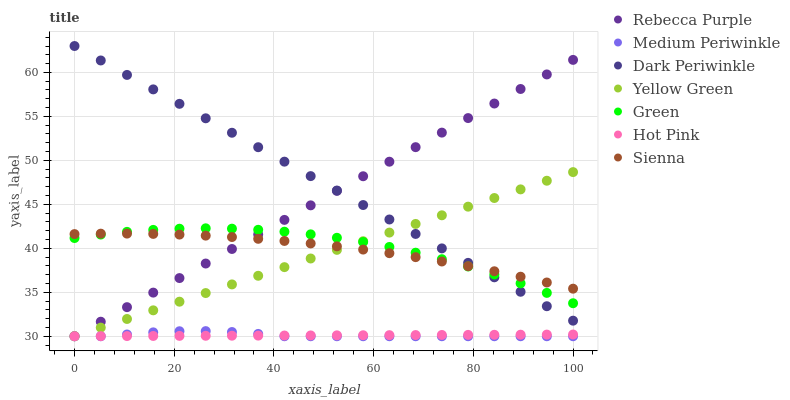Does Hot Pink have the minimum area under the curve?
Answer yes or no. Yes. Does Dark Periwinkle have the maximum area under the curve?
Answer yes or no. Yes. Does Medium Periwinkle have the minimum area under the curve?
Answer yes or no. No. Does Medium Periwinkle have the maximum area under the curve?
Answer yes or no. No. Is Hot Pink the smoothest?
Answer yes or no. Yes. Is Green the roughest?
Answer yes or no. Yes. Is Medium Periwinkle the smoothest?
Answer yes or no. No. Is Medium Periwinkle the roughest?
Answer yes or no. No. Does Yellow Green have the lowest value?
Answer yes or no. Yes. Does Sienna have the lowest value?
Answer yes or no. No. Does Dark Periwinkle have the highest value?
Answer yes or no. Yes. Does Medium Periwinkle have the highest value?
Answer yes or no. No. Is Medium Periwinkle less than Sienna?
Answer yes or no. Yes. Is Dark Periwinkle greater than Hot Pink?
Answer yes or no. Yes. Does Sienna intersect Dark Periwinkle?
Answer yes or no. Yes. Is Sienna less than Dark Periwinkle?
Answer yes or no. No. Is Sienna greater than Dark Periwinkle?
Answer yes or no. No. Does Medium Periwinkle intersect Sienna?
Answer yes or no. No. 